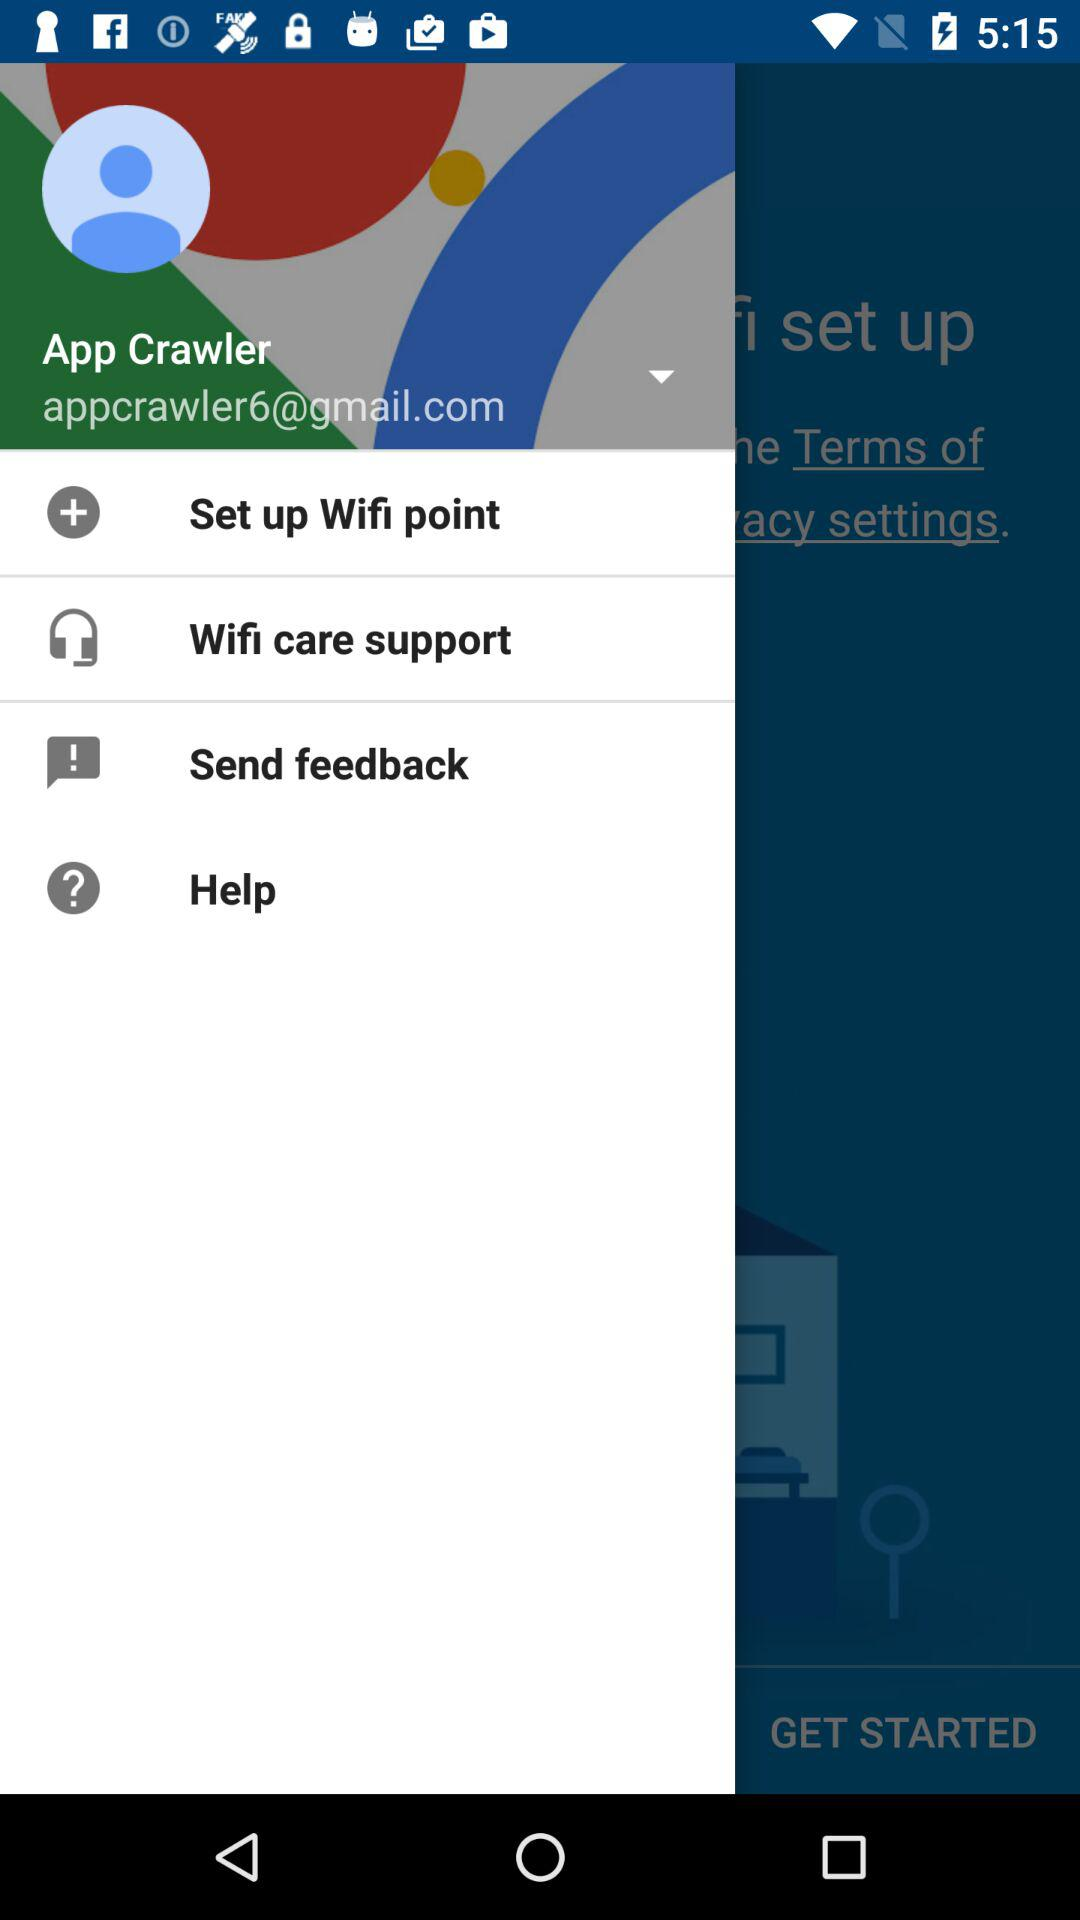What is the email address? The email address is appcrawler6@gmail.com. 